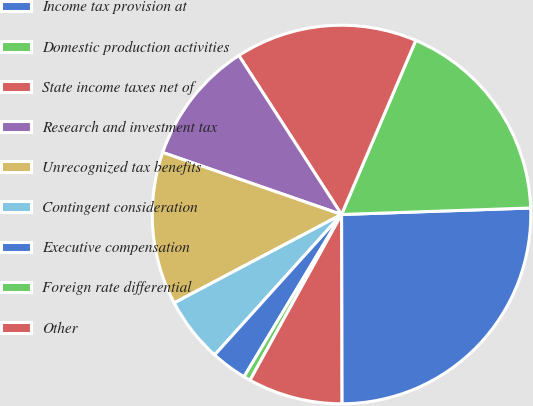Convert chart. <chart><loc_0><loc_0><loc_500><loc_500><pie_chart><fcel>Income tax provision at<fcel>Domestic production activities<fcel>State income taxes net of<fcel>Research and investment tax<fcel>Unrecognized tax benefits<fcel>Contingent consideration<fcel>Executive compensation<fcel>Foreign rate differential<fcel>Other<nl><fcel>25.52%<fcel>18.04%<fcel>15.54%<fcel>10.56%<fcel>13.05%<fcel>5.57%<fcel>3.08%<fcel>0.58%<fcel>8.06%<nl></chart> 